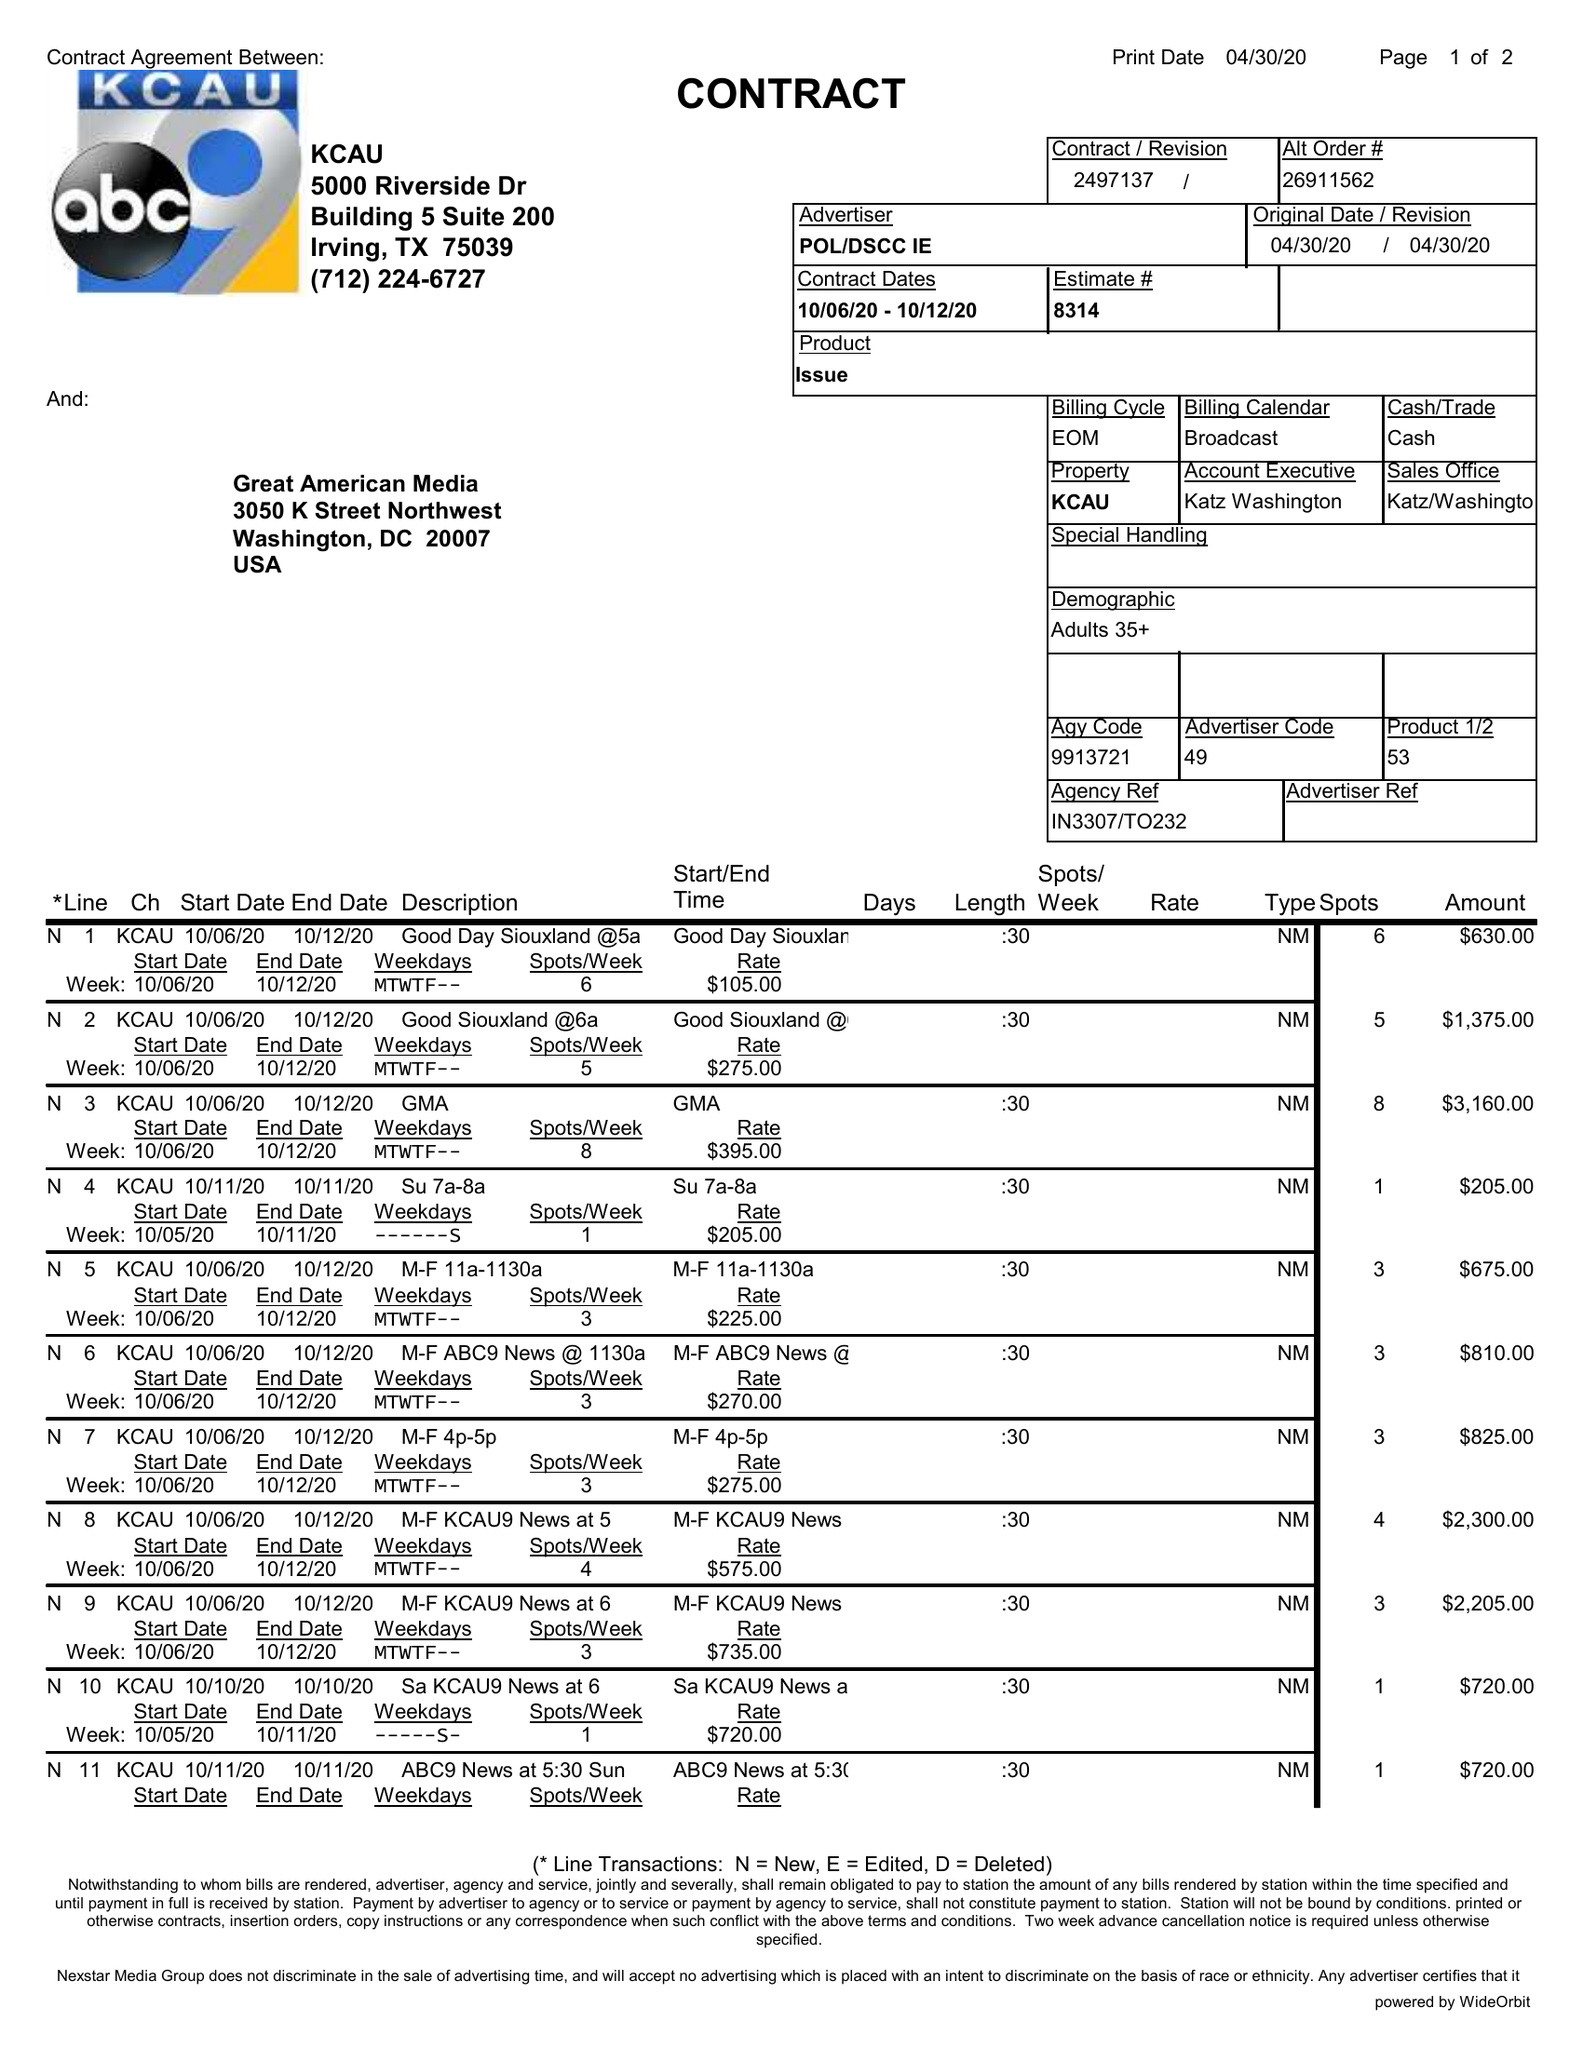What is the value for the contract_num?
Answer the question using a single word or phrase. 2497137 